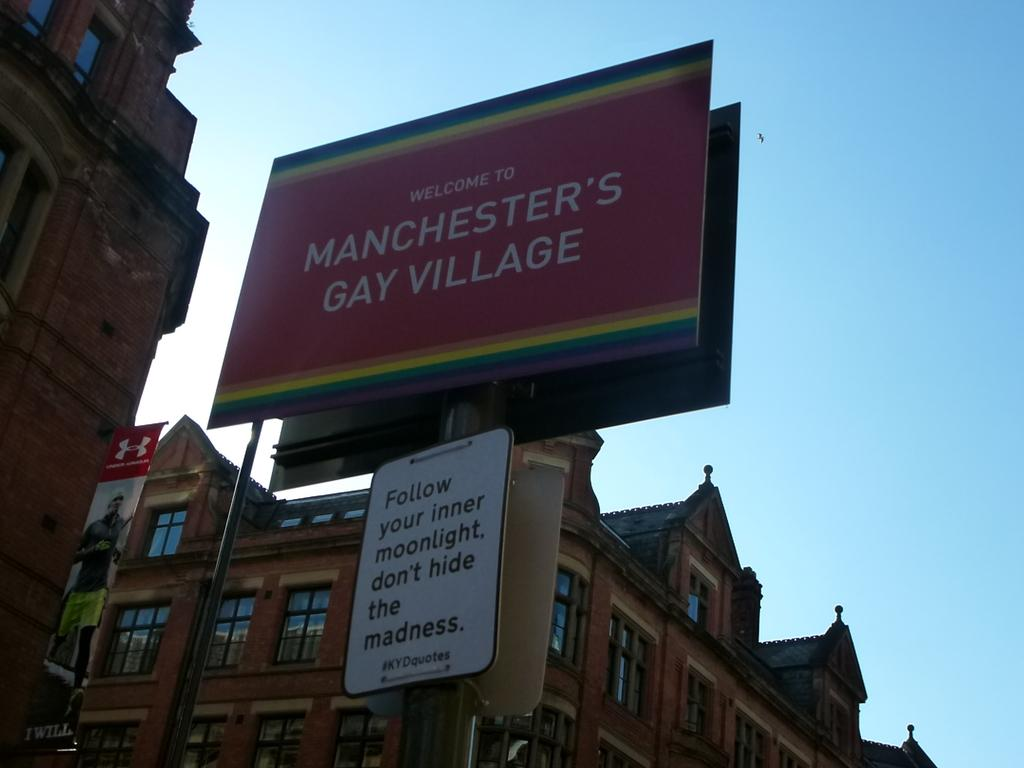Provide a one-sentence caption for the provided image. The city has a gay area in this neighborhood called Manchester's Gay Village. 